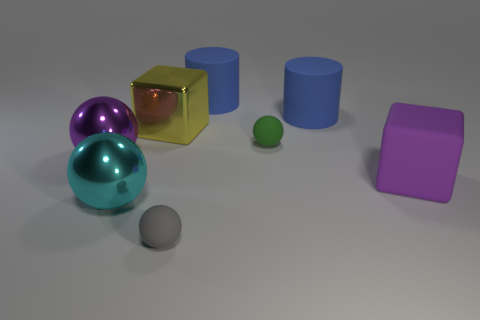Subtract all green rubber balls. How many balls are left? 3 Add 1 brown matte blocks. How many objects exist? 9 Subtract all cyan balls. How many balls are left? 3 Subtract all cubes. How many objects are left? 6 Subtract all cyan cylinders. Subtract all purple balls. How many cylinders are left? 2 Subtract all big green things. Subtract all matte spheres. How many objects are left? 6 Add 5 blocks. How many blocks are left? 7 Add 5 tiny rubber balls. How many tiny rubber balls exist? 7 Subtract 0 green cylinders. How many objects are left? 8 